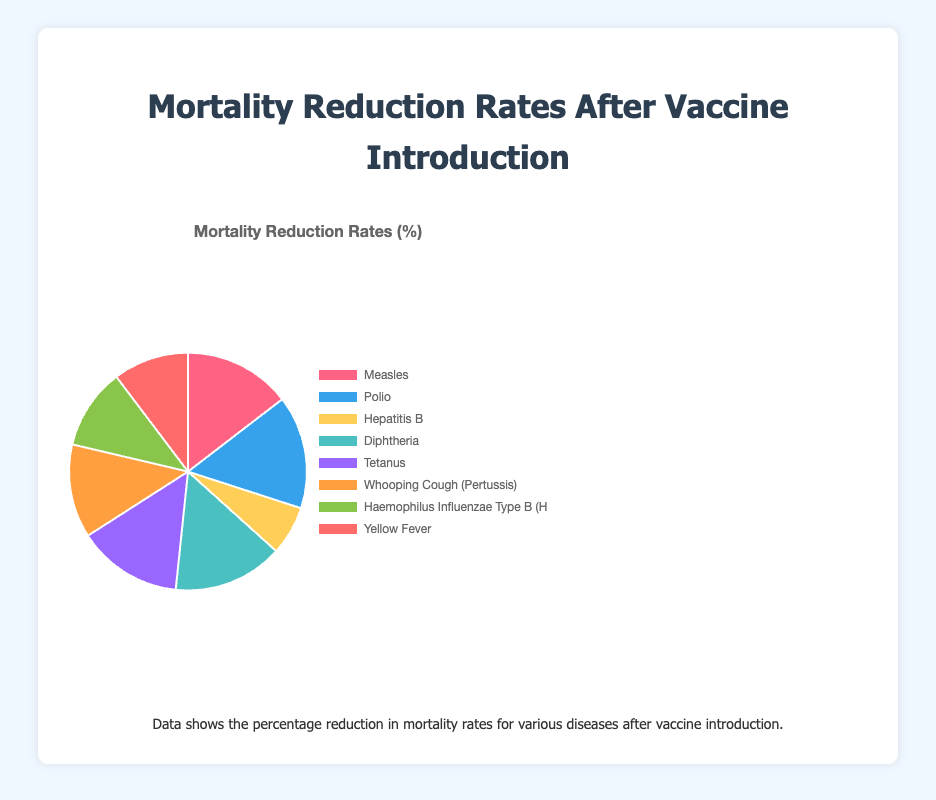Which disease has the highest mortality reduction rate after vaccination introduction? Look at the sectors in the chart and identify which one shows the highest percentage reduction. The data indicates Polio with a 99.8% reduction
Answer: Polio Which disease has the lowest mortality reduction rate after vaccination introduction? Look at the sectors in the chart and identify the lowest percentage reduction. The lowest rate is 43.3%, corresponding to Hepatitis B
Answer: Hepatitis B What is the difference in mortality reduction rates between Measles and Hepatitis B? Identify the respective reduction rates for Measles (94.4%) and Hepatitis B (43.3%), then calculate the difference: 94.4% - 43.3% = 51.1%
Answer: 51.1% Is the mortality reduction rate for Yellow Fever greater than that for Haemophilus Influenzae Type B? Compare the reduction rates for Yellow Fever (66.7%) and Haemophilus Influenzae Type B (71.4%) to see if 66.7% < 71.4%
Answer: No Which disease shows a mortality reduction rate closest to 90%? Look through the chart and identify the reduction rate closest to 90%. Tetanus shows a rate of 92.5%, which is closest to 90%
Answer: Tetanus What is the combined mortality reduction rate for Polio, Diphtheria, and Tetanus? Extract the rates: Polio (99.8%), Diphtheria (97%), and Tetanus (92.5%), then average them: (99.8% + 97% + 92.5%) / 3 = 96.43%
Answer: 96.43% Are there more diseases with mortality reduction rates above 90% or below 70%? Count the diseases in each category from the chart. Above 90%: Measles, Polio, Diphtheria, Tetanus (4). Below 70%: Hepatitis B, Yellow Fever (2)
Answer: Above 90% Which color represents the highest mortality reduction rate sector in the pie chart? Check the sector with the highest percentage and match its color. The Polio sector has the highest reduction rate and is colored blue
Answer: Blue Do Diphtheria and Whooping Cough (Pertussis) together account for more or less than half of the total mortality reduction percentages shown? Sum the percentages for Diphtheria (97%) and Whooping Cough (82.5%): 97% + 82.5% = 179.5%. Since there are 8 diseases, half of the total percentages (800%) is 400%. 179.5% < 400%
Answer: Less What is the average mortality reduction rate for all the diseases listed? Add all the reduction rates and divide by the number of diseases: (94.4% + 99.8% + 43.3% + 97% + 92.5% + 82.5% + 71.4% + 66.7%) / 8 = 80.95%
Answer: 80.95% 